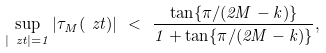Convert formula to latex. <formula><loc_0><loc_0><loc_500><loc_500>\sup _ { | \ z t | = 1 } | \tau _ { M } ( \ z t ) | \ < \ \frac { \tan \{ \pi / ( 2 M - k ) \} } { 1 + \tan \{ \pi / ( 2 M - k ) \} } ,</formula> 